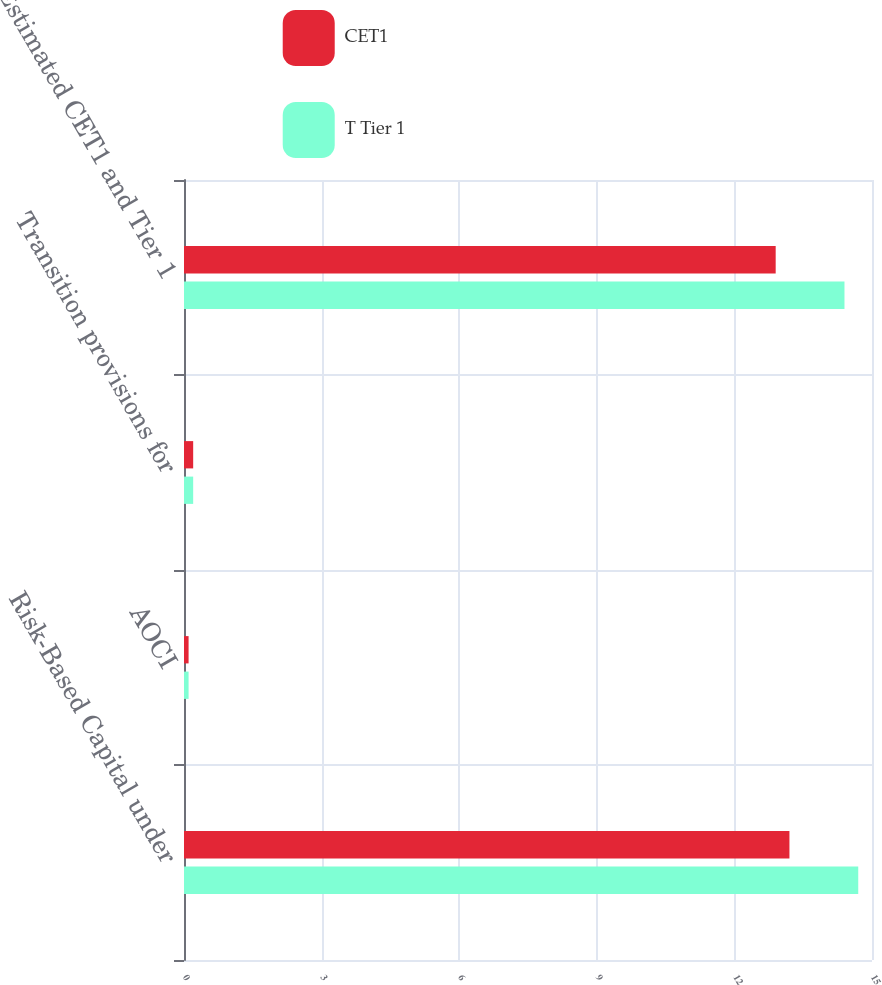Convert chart. <chart><loc_0><loc_0><loc_500><loc_500><stacked_bar_chart><ecel><fcel>Risk-Based Capital under<fcel>AOCI<fcel>Transition provisions for<fcel>Estimated CET1 and Tier 1<nl><fcel>CET1<fcel>13.2<fcel>0.1<fcel>0.2<fcel>12.9<nl><fcel>T Tier 1<fcel>14.7<fcel>0.1<fcel>0.2<fcel>14.4<nl></chart> 